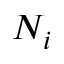<formula> <loc_0><loc_0><loc_500><loc_500>N _ { i }</formula> 